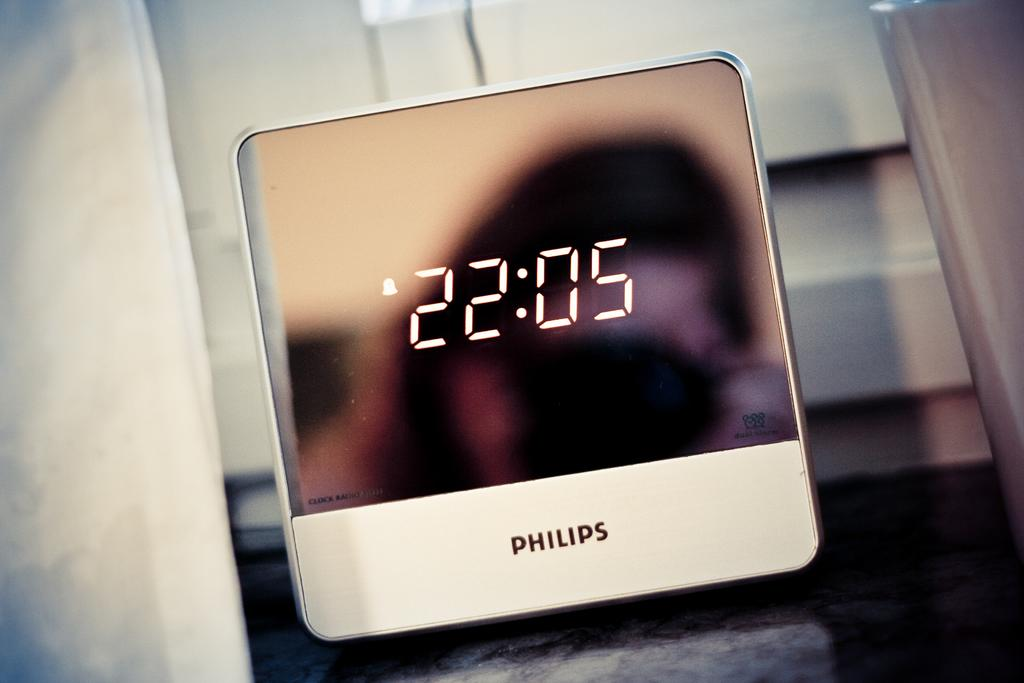<image>
Describe the image concisely. A screen with Philips and 20:05 on the screen. 